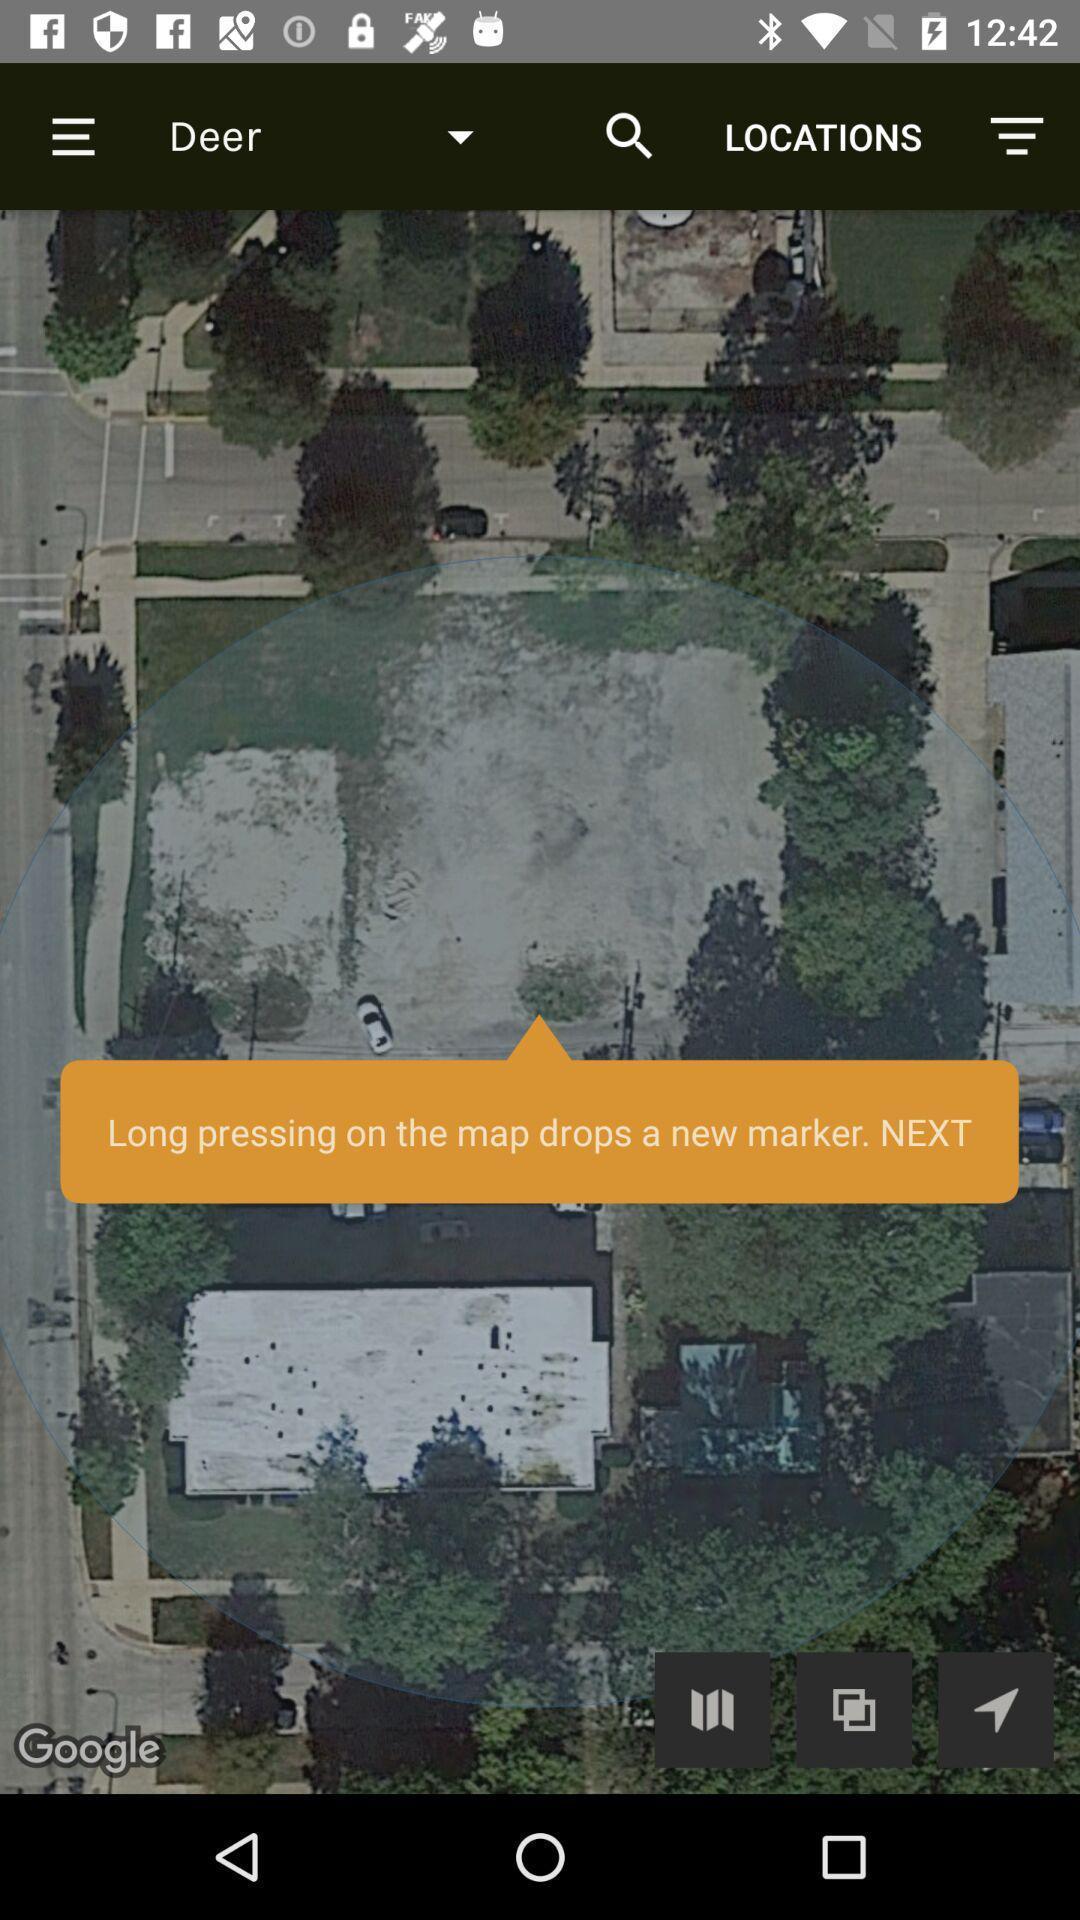Provide a textual representation of this image. Pop up to long press. 